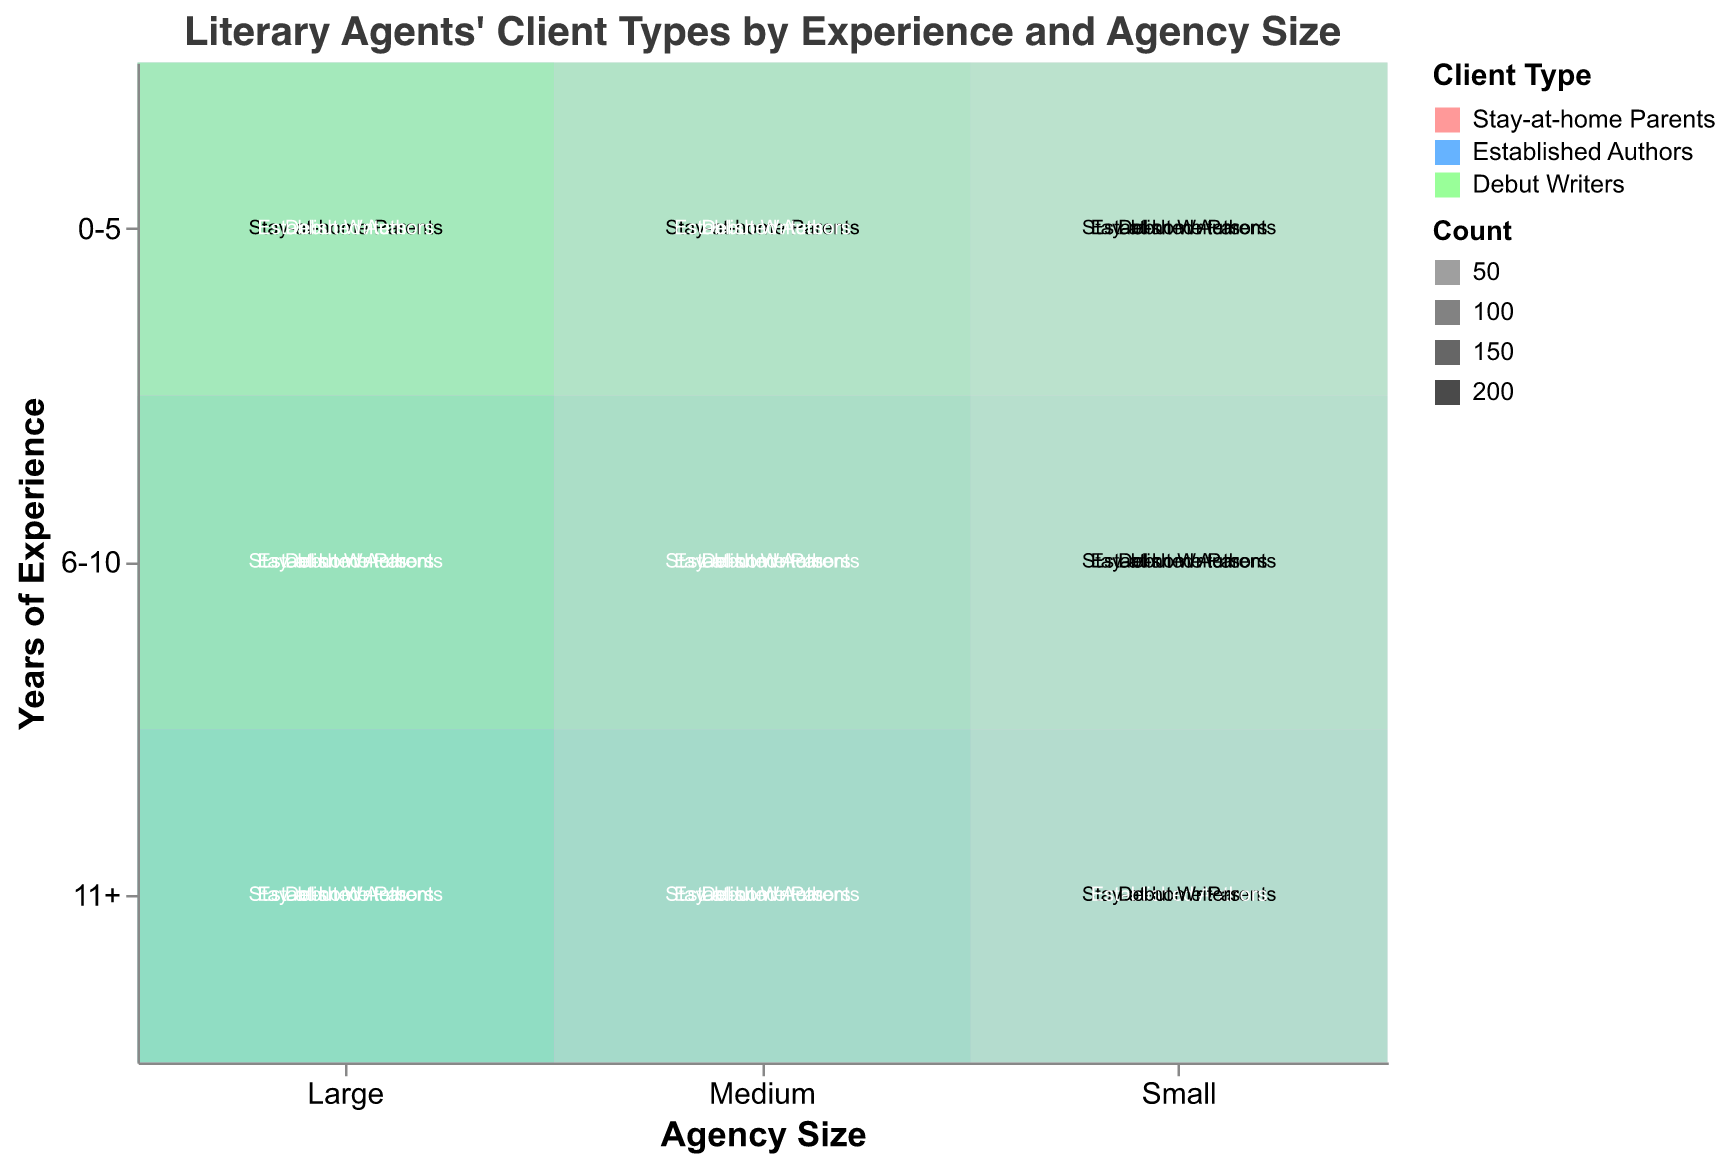How many stay-at-home parents are represented in large agencies with 6-10 years of experience? To find the number of stay-at-home parents in large agencies with 6-10 years of experience, look for the cell where "Agency Size" is "Large" and "Years of Experience" is "6-10", then refer to the "Stay-at-home Parents" category.
Answer: 120 Which agency size has the highest number of debut writers who have 11+ years of experience? To determine which agency size has the highest number of debut writers with 11+ years of experience, find the cell that matches "11+ years of experience" and "Debut Writers" for all agency sizes. Compare the counts.
Answer: Large What is the dominant client type in small agencies with 0-5 years of experience? To find the dominant client type in small agencies with 0-5 years of experience, observe the three client types (Stay-at-home Parents, Established Authors, Debut Writers) and see which has the largest count in the "Small" and "0-5" cell.
Answer: Debut Writers How does the number of established authors compare between medium agencies with 6-10 years of experience and small agencies with 6-10 years of experience? Compare the counts of "Established Authors" in "Medium" and "Small" agency sizes with "6-10 years of experience". Medium has 90 established authors, while Small has 45.
Answer: Medium has double the number What is the total number of clients in large agencies with 11+ years of experience? To find the total number of clients in large agencies with 11+ years of experience, sum the counts of Stay-at-home Parents, Established Authors, and Debut Writers for "Large" agencies with "11+" years of experience: 160 + 240 + 120.
Answer: 520 